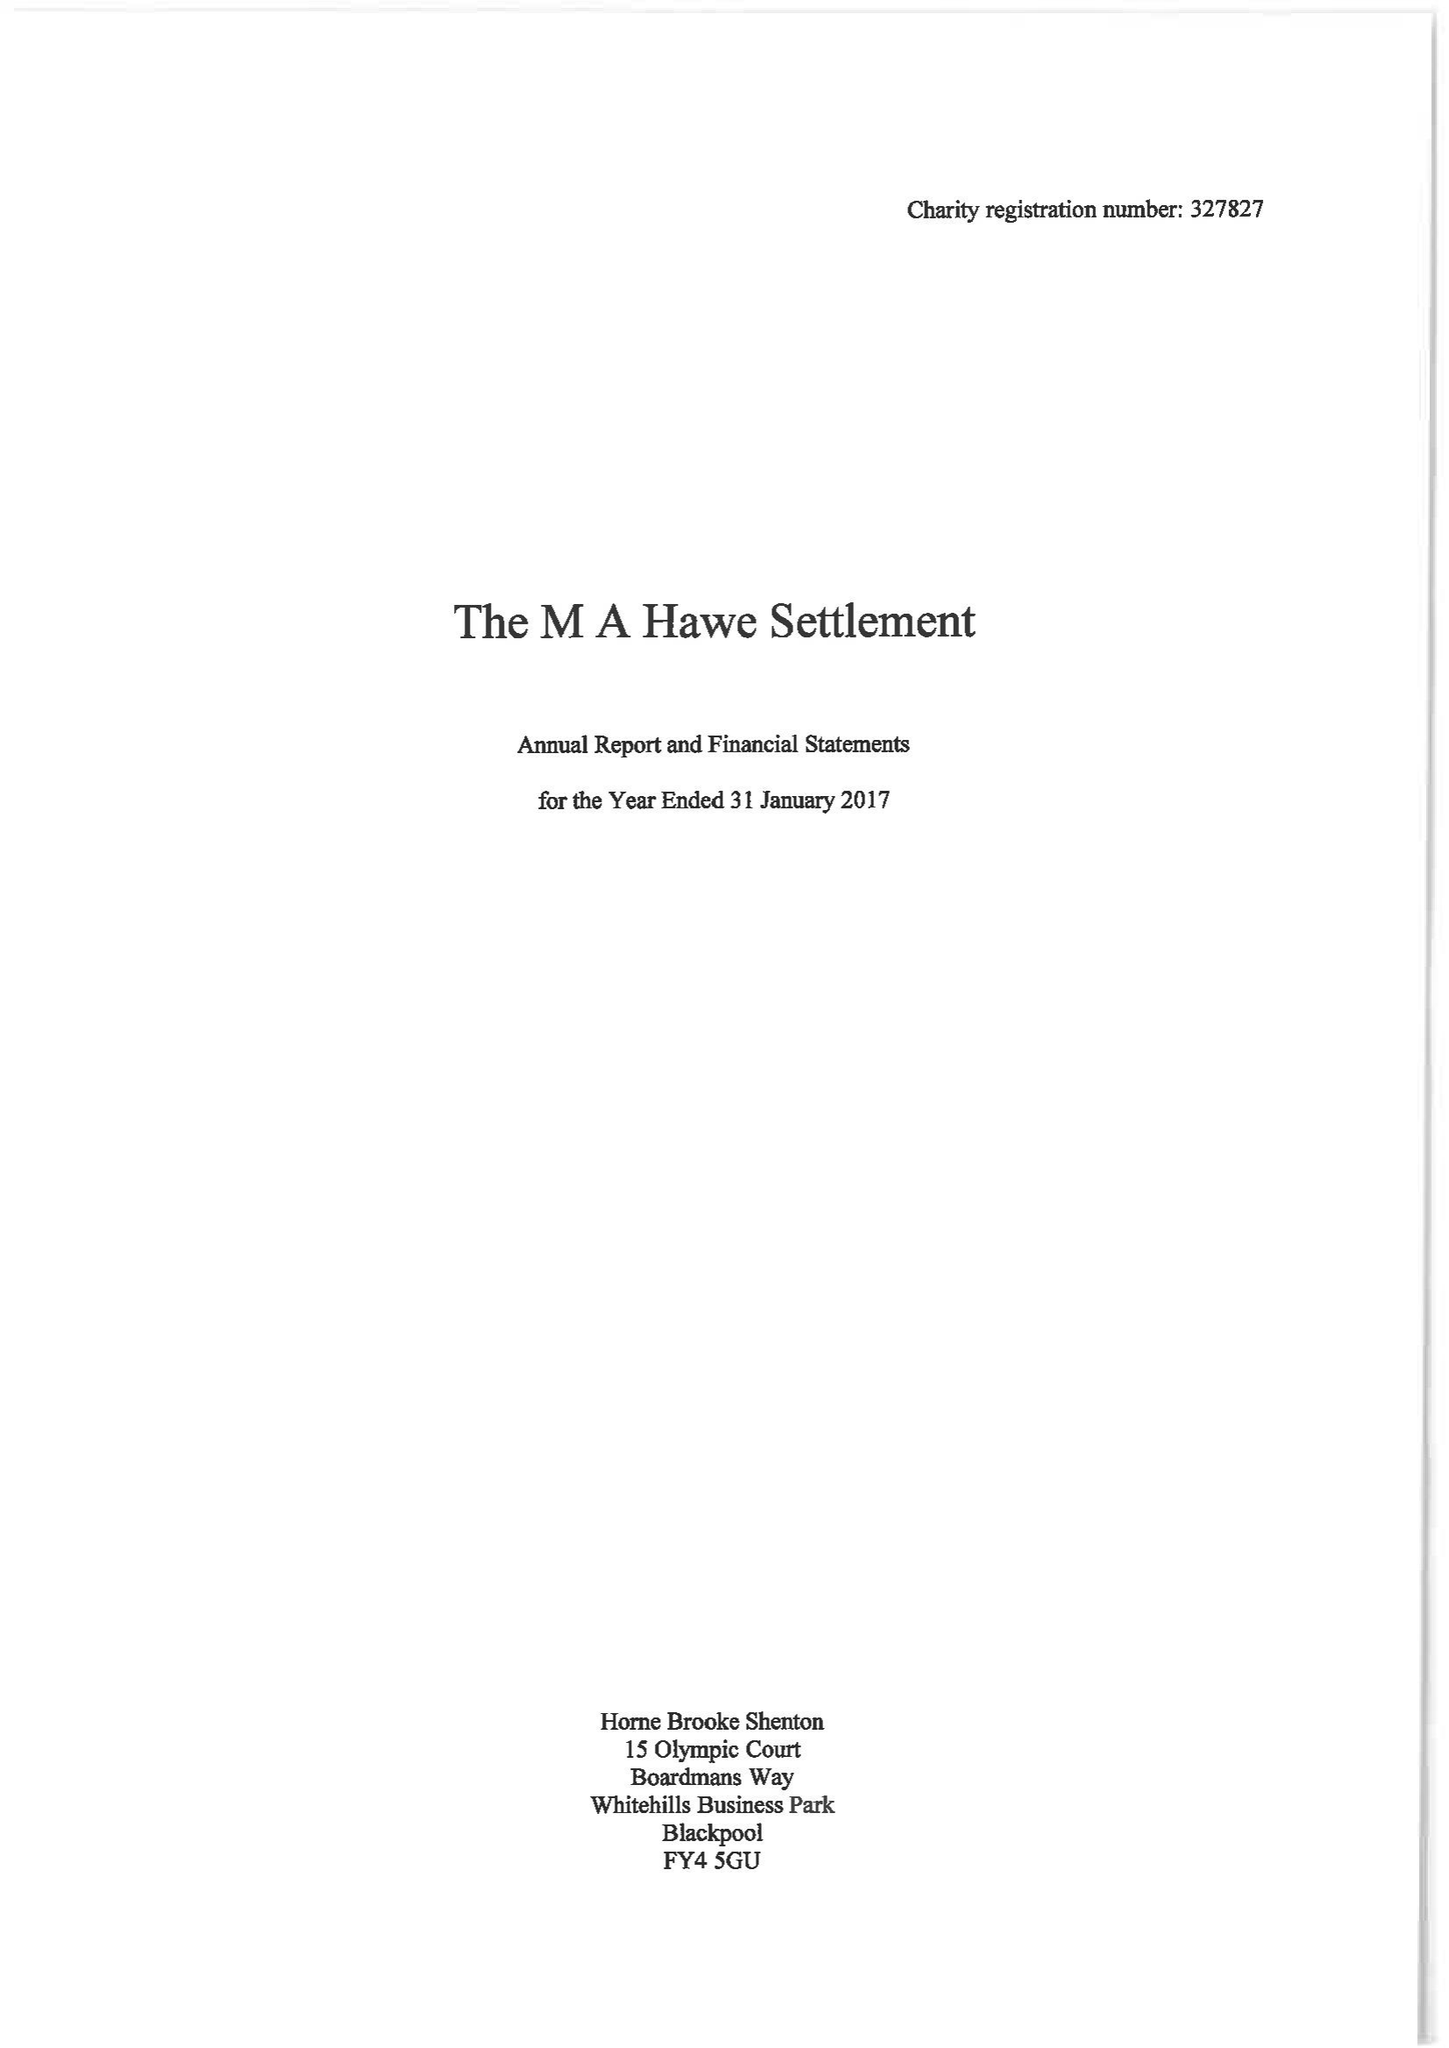What is the value for the address__post_town?
Answer the question using a single word or phrase. LYTHAM ST. ANNES 